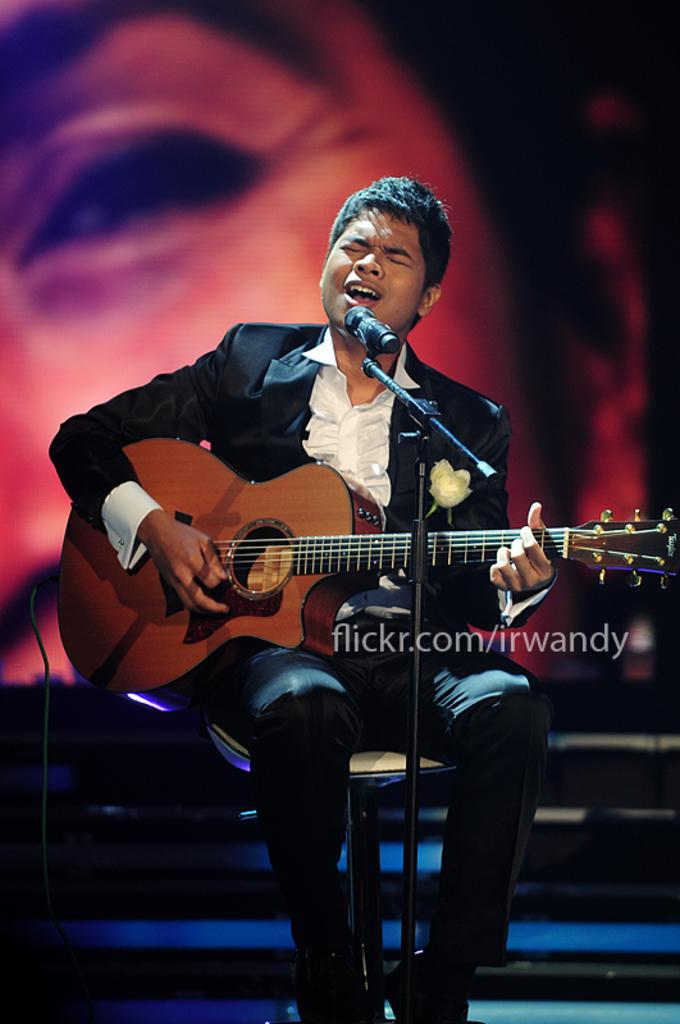What is the person in the image doing while sitting on the chair? The person is playing a guitar and singing. What object is in front of the person to help amplify their voice? There is a microphone with a stand in front of the person. Can you describe the background of the image? There is a person's face visible in the background. What type of seed is the person planting in the image? There is no seed present in the image. 